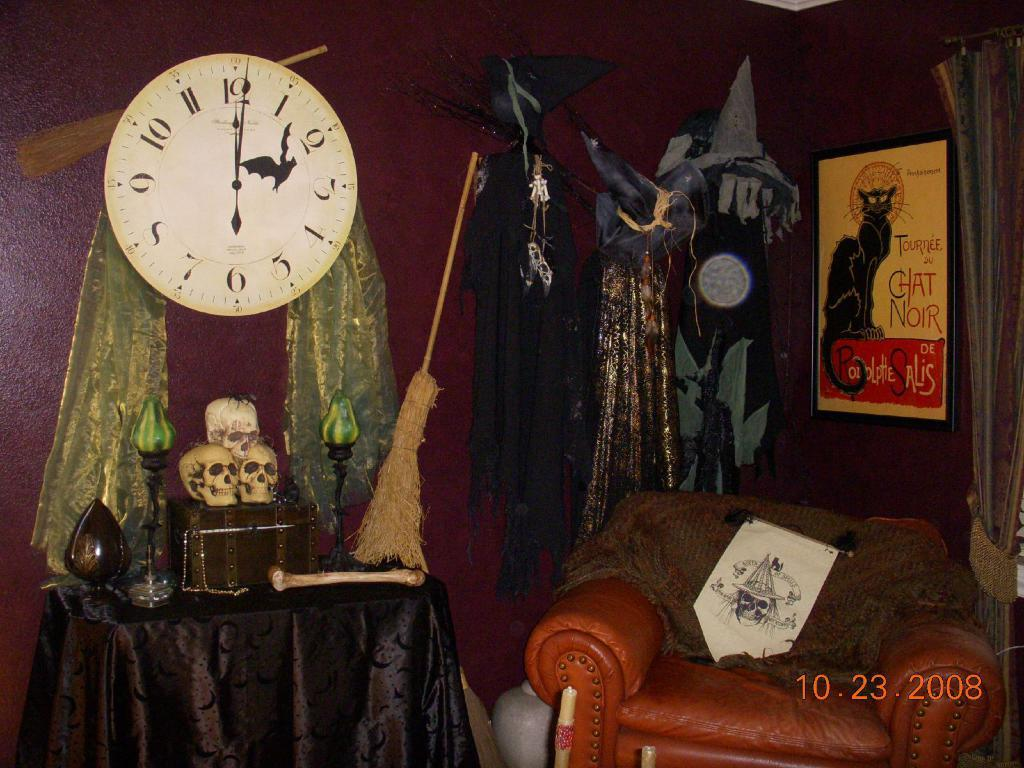<image>
Write a terse but informative summary of the picture. A clock reads just after midnight in a spooky looking room. 